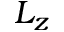<formula> <loc_0><loc_0><loc_500><loc_500>L _ { z }</formula> 